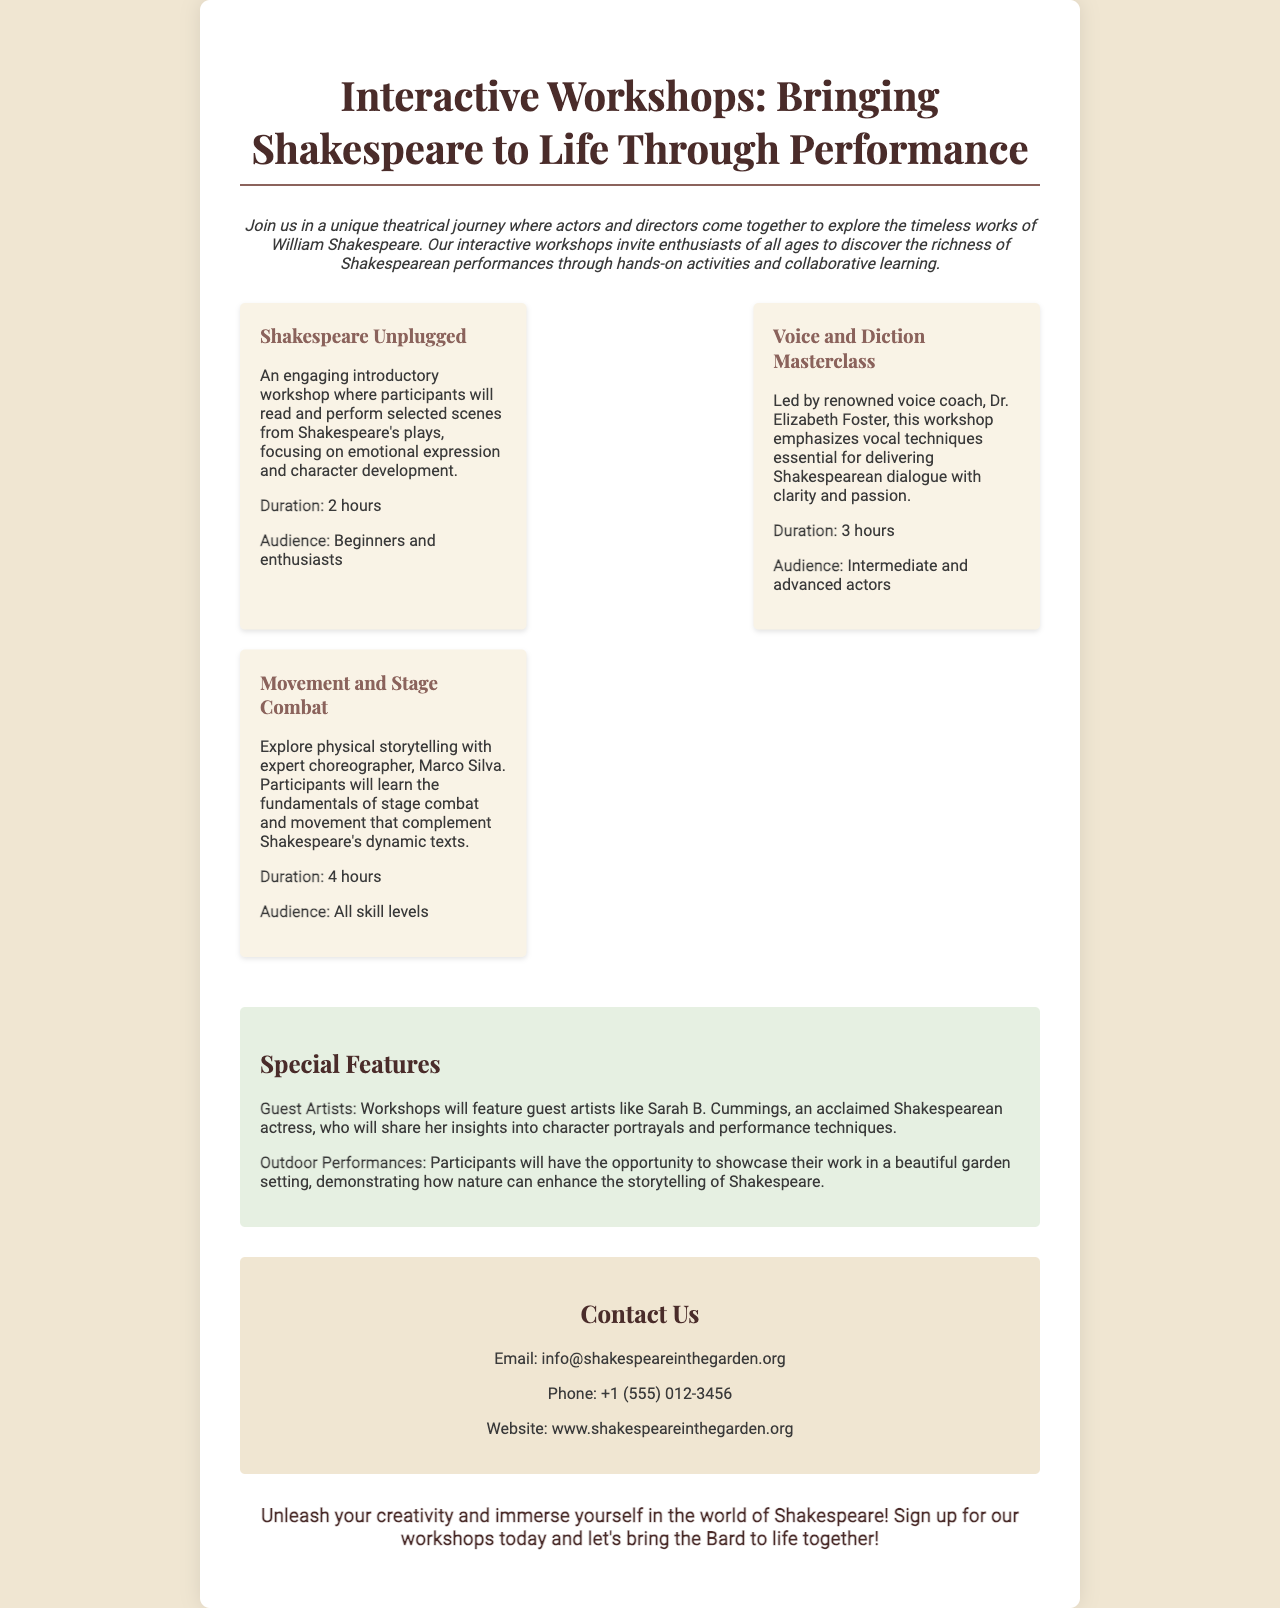What is the title of the workshops? The title of the workshops is presented prominently at the top of the brochure.
Answer: Interactive Workshops: Bringing Shakespeare to Life Through Performance Who is the voice coach leading a masterclass? The document mentions a specific voice coach who is leading one of the workshops.
Answer: Dr. Elizabeth Foster What is the duration of the Movement and Stage Combat workshop? The duration of each workshop is specified in the short descriptions provided.
Answer: 4 hours What audience is the Shakespeare Unplugged workshop aimed at? Each workshop includes an audience description to guide potential participants.
Answer: Beginners and enthusiasts What special feature involves guest artists? The document describes a special feature related to guest appearances by professionals in the field.
Answer: Guest Artists What phrase encourages participants to sign up for the workshops? A call to action at the end of the brochure motivates attendees to join.
Answer: Unleash your creativity and immerse yourself in the world of Shakespeare! 